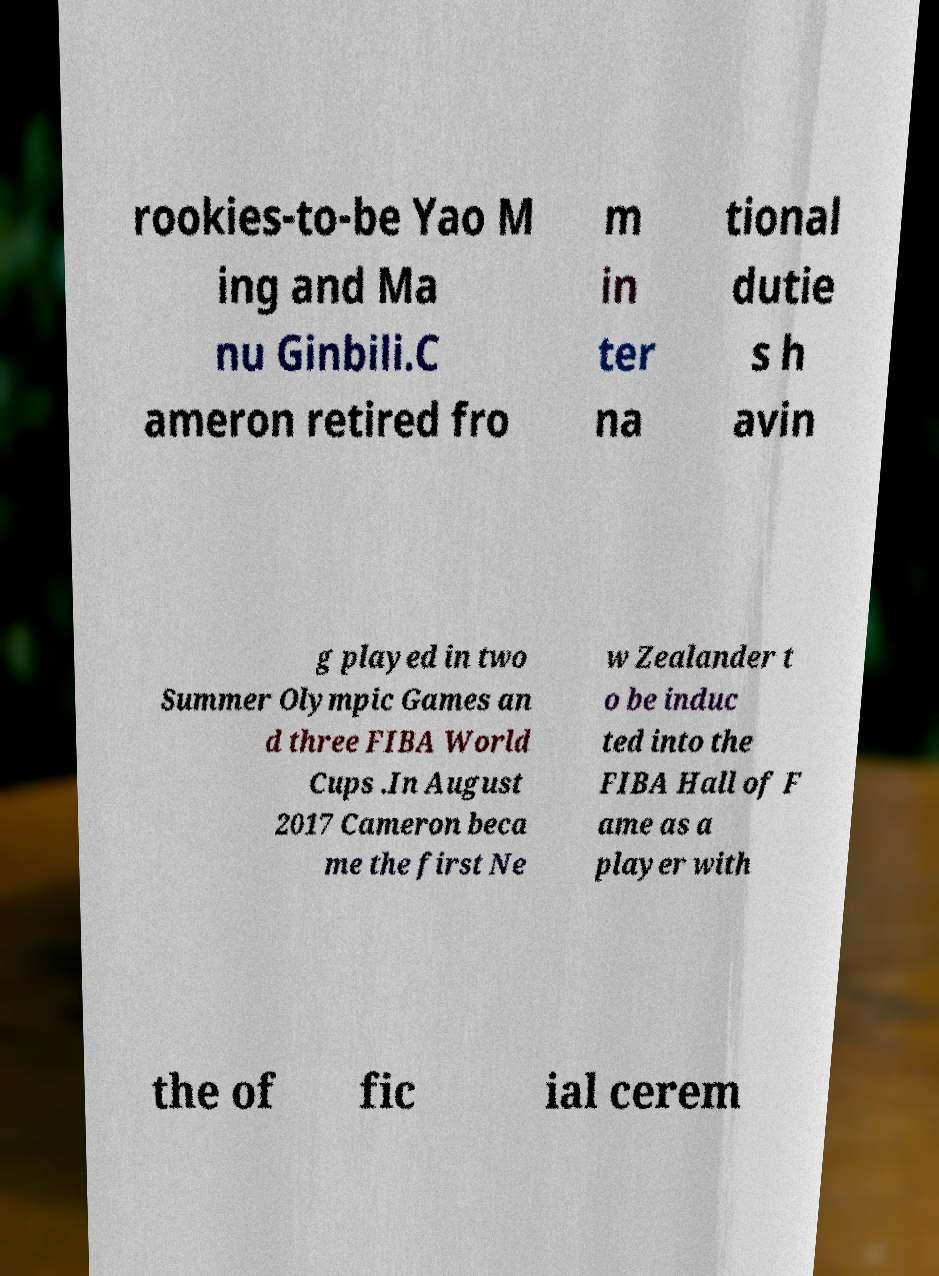For documentation purposes, I need the text within this image transcribed. Could you provide that? rookies-to-be Yao M ing and Ma nu Ginbili.C ameron retired fro m in ter na tional dutie s h avin g played in two Summer Olympic Games an d three FIBA World Cups .In August 2017 Cameron beca me the first Ne w Zealander t o be induc ted into the FIBA Hall of F ame as a player with the of fic ial cerem 